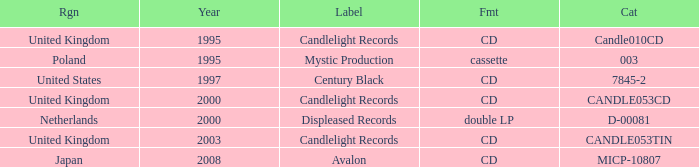What was the Candlelight Records Catalog of Candle053tin format? CD. 